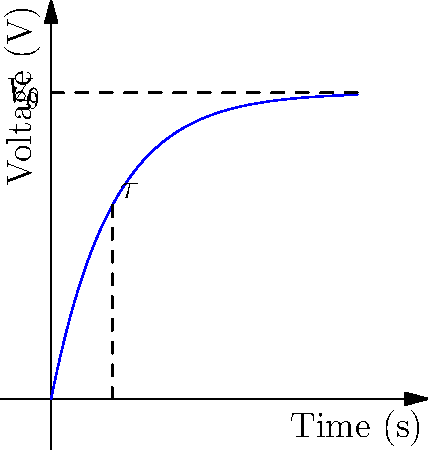As a horse trainer who understands the importance of timing in races, analyze the voltage-time graph of an RC circuit charging process. If the final voltage $V_0$ represents the horse's peak performance and $\tau$ (tau) represents the time constant, at what percentage of $V_0$ will the voltage be when $t = \tau$? Let's approach this step-by-step:

1) The voltage in an RC circuit during charging follows the equation:
   $V(t) = V_0(1 - e^{-t/\tau})$

2) We want to find $V(\tau)$, so we substitute $t = \tau$:
   $V(\tau) = V_0(1 - e^{-\tau/\tau}) = V_0(1 - e^{-1})$

3) Now, let's calculate $e^{-1}$:
   $e^{-1} \approx 0.368$

4) Therefore:
   $V(\tau) = V_0(1 - 0.368) = 0.632V_0$

5) To express this as a percentage of $V_0$:
   $\frac{V(\tau)}{V_0} \times 100\% = 0.632 \times 100\% = 63.2\%$

This means that when $t = \tau$, the voltage will have reached approximately 63.2% of its final value $V_0$.

In the context of horse training, this could be interpreted as the horse reaching about 63% of its peak performance after one time constant of training or warm-up.
Answer: 63.2% of $V_0$ 